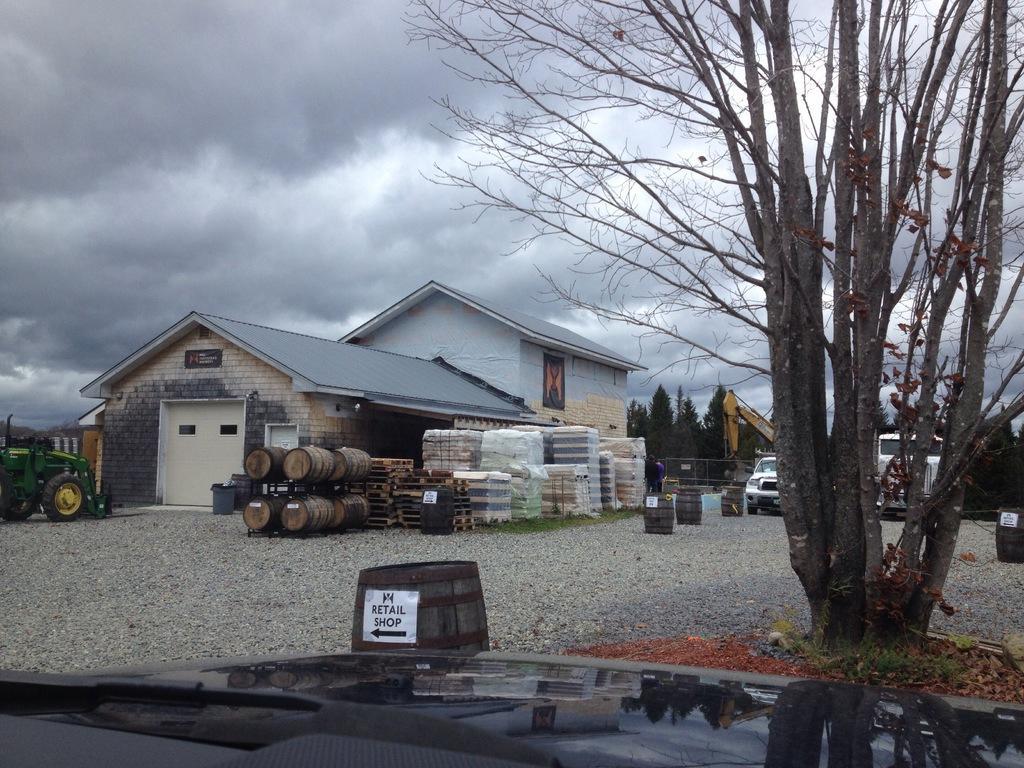In one or two sentences, can you explain what this image depicts? In front of the image there is bonnet of a vehicle, in front of the bonnet there is a dried tree with branches, on the surface there are stones and there are barrels, tractor, cars, crane, a building, trash can, wooden objects, behind the building there are trees and there is a metal rod mesh fence, in the sky there are clouds. 